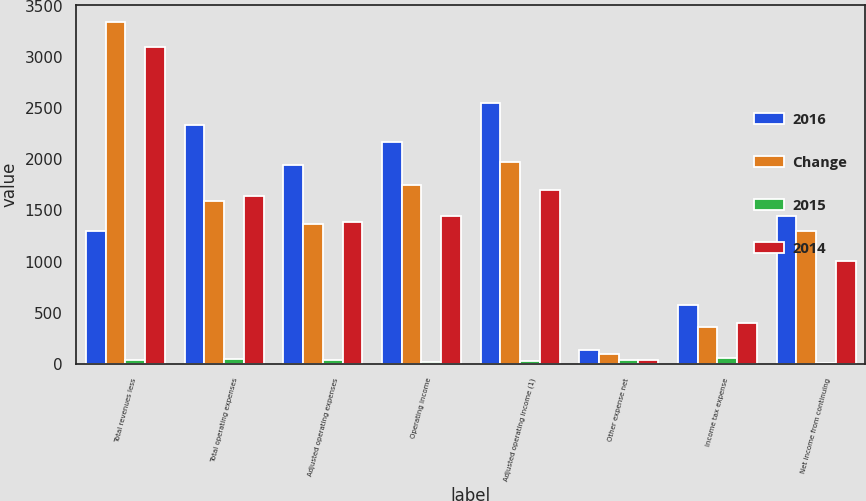Convert chart to OTSL. <chart><loc_0><loc_0><loc_500><loc_500><stacked_bar_chart><ecel><fcel>Total revenues less<fcel>Total operating expenses<fcel>Adjusted operating expenses<fcel>Operating income<fcel>Adjusted operating income (1)<fcel>Other expense net<fcel>Income tax expense<fcel>Net income from continuing<nl><fcel>2016<fcel>1295<fcel>2332<fcel>1947<fcel>2167<fcel>2552<fcel>138<fcel>580<fcel>1449<nl><fcel>Change<fcel>3338<fcel>1588<fcel>1365<fcel>1750<fcel>1973<fcel>97<fcel>358<fcel>1295<nl><fcel>2015<fcel>35<fcel>47<fcel>43<fcel>24<fcel>29<fcel>42<fcel>62<fcel>12<nl><fcel>2014<fcel>3092<fcel>1644<fcel>1389<fcel>1448<fcel>1703<fcel>41<fcel>402<fcel>1005<nl></chart> 